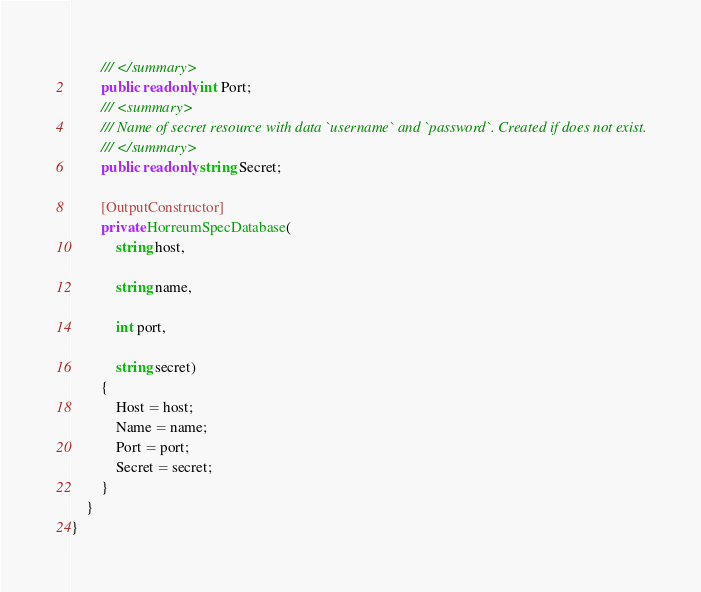<code> <loc_0><loc_0><loc_500><loc_500><_C#_>        /// </summary>
        public readonly int Port;
        /// <summary>
        /// Name of secret resource with data `username` and `password`. Created if does not exist.
        /// </summary>
        public readonly string Secret;

        [OutputConstructor]
        private HorreumSpecDatabase(
            string host,

            string name,

            int port,

            string secret)
        {
            Host = host;
            Name = name;
            Port = port;
            Secret = secret;
        }
    }
}
</code> 